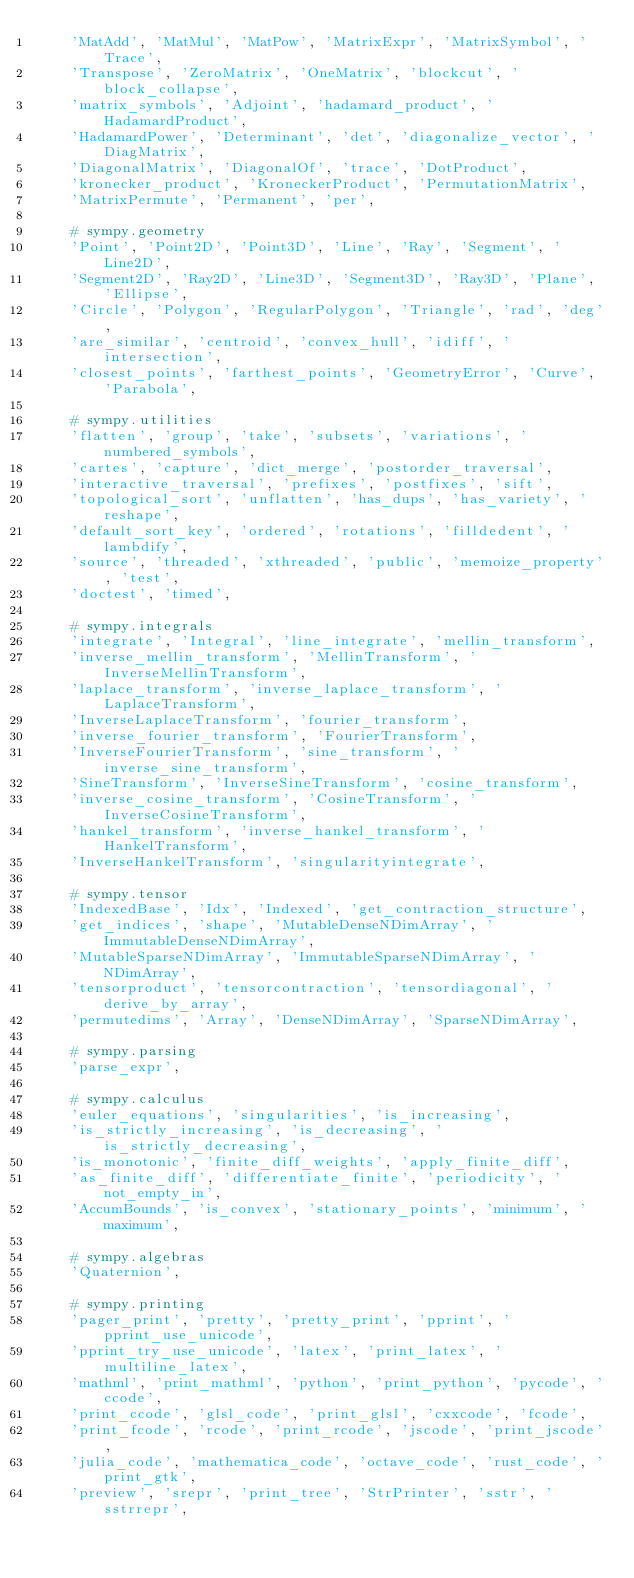Convert code to text. <code><loc_0><loc_0><loc_500><loc_500><_Python_>    'MatAdd', 'MatMul', 'MatPow', 'MatrixExpr', 'MatrixSymbol', 'Trace',
    'Transpose', 'ZeroMatrix', 'OneMatrix', 'blockcut', 'block_collapse',
    'matrix_symbols', 'Adjoint', 'hadamard_product', 'HadamardProduct',
    'HadamardPower', 'Determinant', 'det', 'diagonalize_vector', 'DiagMatrix',
    'DiagonalMatrix', 'DiagonalOf', 'trace', 'DotProduct',
    'kronecker_product', 'KroneckerProduct', 'PermutationMatrix',
    'MatrixPermute', 'Permanent', 'per',

    # sympy.geometry
    'Point', 'Point2D', 'Point3D', 'Line', 'Ray', 'Segment', 'Line2D',
    'Segment2D', 'Ray2D', 'Line3D', 'Segment3D', 'Ray3D', 'Plane', 'Ellipse',
    'Circle', 'Polygon', 'RegularPolygon', 'Triangle', 'rad', 'deg',
    'are_similar', 'centroid', 'convex_hull', 'idiff', 'intersection',
    'closest_points', 'farthest_points', 'GeometryError', 'Curve', 'Parabola',

    # sympy.utilities
    'flatten', 'group', 'take', 'subsets', 'variations', 'numbered_symbols',
    'cartes', 'capture', 'dict_merge', 'postorder_traversal',
    'interactive_traversal', 'prefixes', 'postfixes', 'sift',
    'topological_sort', 'unflatten', 'has_dups', 'has_variety', 'reshape',
    'default_sort_key', 'ordered', 'rotations', 'filldedent', 'lambdify',
    'source', 'threaded', 'xthreaded', 'public', 'memoize_property', 'test',
    'doctest', 'timed',

    # sympy.integrals
    'integrate', 'Integral', 'line_integrate', 'mellin_transform',
    'inverse_mellin_transform', 'MellinTransform', 'InverseMellinTransform',
    'laplace_transform', 'inverse_laplace_transform', 'LaplaceTransform',
    'InverseLaplaceTransform', 'fourier_transform',
    'inverse_fourier_transform', 'FourierTransform',
    'InverseFourierTransform', 'sine_transform', 'inverse_sine_transform',
    'SineTransform', 'InverseSineTransform', 'cosine_transform',
    'inverse_cosine_transform', 'CosineTransform', 'InverseCosineTransform',
    'hankel_transform', 'inverse_hankel_transform', 'HankelTransform',
    'InverseHankelTransform', 'singularityintegrate',

    # sympy.tensor
    'IndexedBase', 'Idx', 'Indexed', 'get_contraction_structure',
    'get_indices', 'shape', 'MutableDenseNDimArray', 'ImmutableDenseNDimArray',
    'MutableSparseNDimArray', 'ImmutableSparseNDimArray', 'NDimArray',
    'tensorproduct', 'tensorcontraction', 'tensordiagonal', 'derive_by_array',
    'permutedims', 'Array', 'DenseNDimArray', 'SparseNDimArray',

    # sympy.parsing
    'parse_expr',

    # sympy.calculus
    'euler_equations', 'singularities', 'is_increasing',
    'is_strictly_increasing', 'is_decreasing', 'is_strictly_decreasing',
    'is_monotonic', 'finite_diff_weights', 'apply_finite_diff',
    'as_finite_diff', 'differentiate_finite', 'periodicity', 'not_empty_in',
    'AccumBounds', 'is_convex', 'stationary_points', 'minimum', 'maximum',

    # sympy.algebras
    'Quaternion',

    # sympy.printing
    'pager_print', 'pretty', 'pretty_print', 'pprint', 'pprint_use_unicode',
    'pprint_try_use_unicode', 'latex', 'print_latex', 'multiline_latex',
    'mathml', 'print_mathml', 'python', 'print_python', 'pycode', 'ccode',
    'print_ccode', 'glsl_code', 'print_glsl', 'cxxcode', 'fcode',
    'print_fcode', 'rcode', 'print_rcode', 'jscode', 'print_jscode',
    'julia_code', 'mathematica_code', 'octave_code', 'rust_code', 'print_gtk',
    'preview', 'srepr', 'print_tree', 'StrPrinter', 'sstr', 'sstrrepr',</code> 